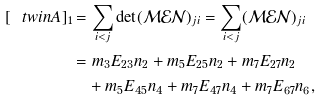<formula> <loc_0><loc_0><loc_500><loc_500>[ \ t w i n A ] _ { 1 } & = \sum _ { i < j } \det ( \mathcal { M } \mathcal { E } \mathcal { N } ) _ { j i } = \sum _ { i < j } ( \mathcal { M } \mathcal { E } \mathcal { N } ) _ { j i } \\ & = m _ { 3 } E _ { 2 3 } n _ { 2 } + m _ { 5 } E _ { 2 5 } n _ { 2 } + m _ { 7 } E _ { 2 7 } n _ { 2 } \\ & \quad + m _ { 5 } E _ { 4 5 } n _ { 4 } + m _ { 7 } E _ { 4 7 } n _ { 4 } + m _ { 7 } E _ { 6 7 } n _ { 6 } ,</formula> 